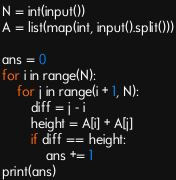Convert code to text. <code><loc_0><loc_0><loc_500><loc_500><_Python_>N = int(input())
A = list(map(int, input().split()))

ans = 0
for i in range(N):
    for j in range(i + 1, N):
        diff = j - i
        height = A[i] + A[j]
        if diff == height:
            ans += 1
print(ans)
</code> 